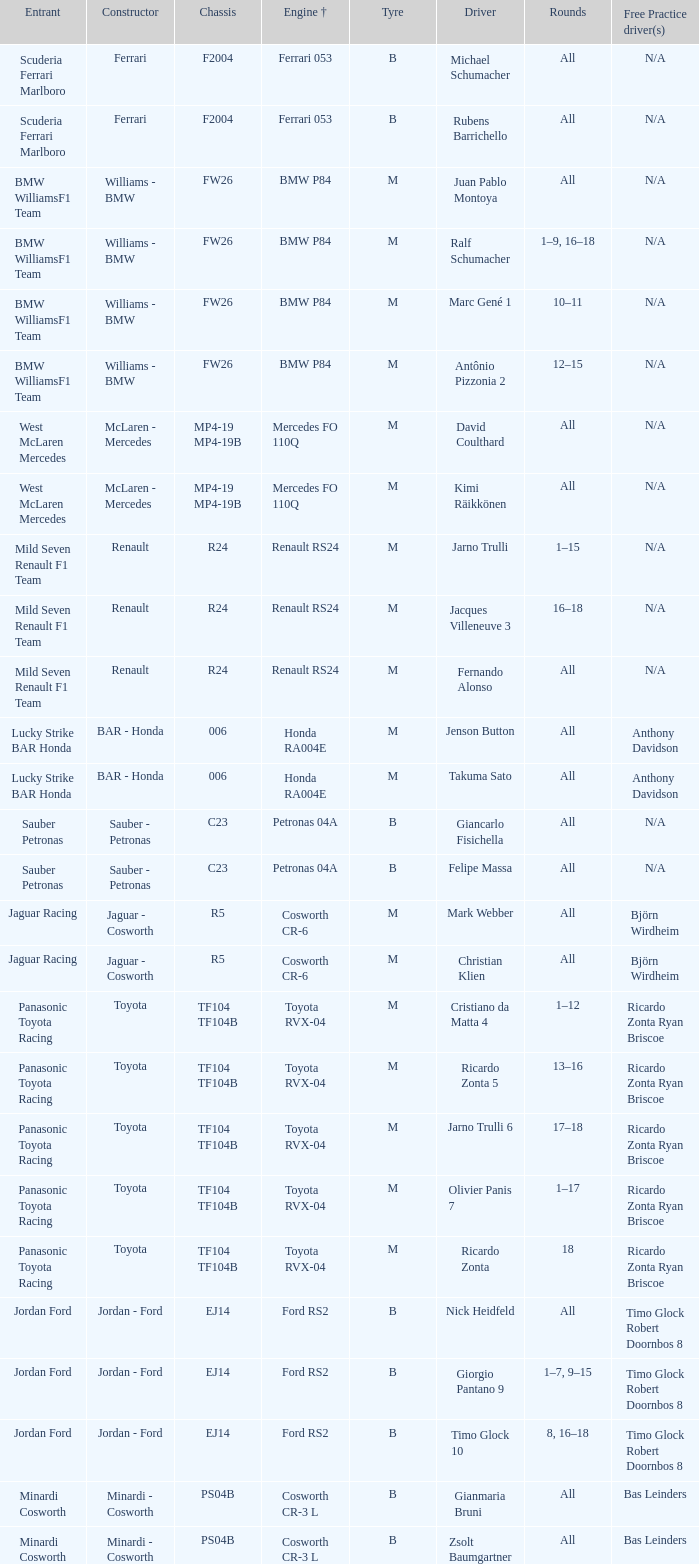What kind of chassis does Ricardo Zonta have? TF104 TF104B. 